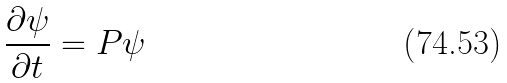<formula> <loc_0><loc_0><loc_500><loc_500>\frac { \partial \psi } { \partial t } = P \psi</formula> 